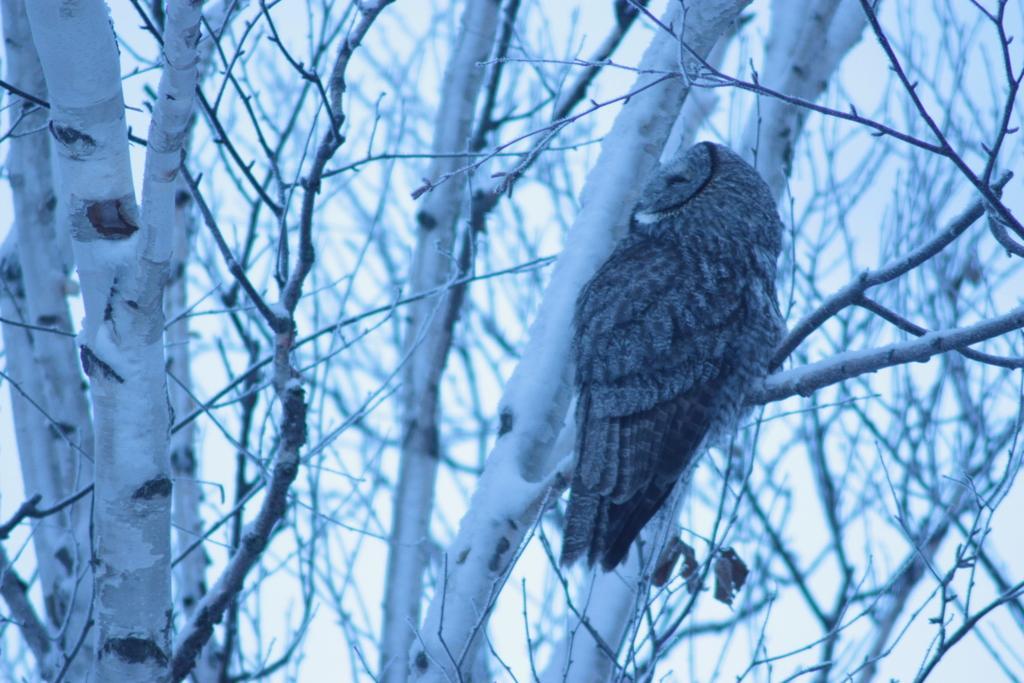How would you summarize this image in a sentence or two? In the foreground I can see an owl is sitting on the branch of a tree and tree trunks. This image is taken may be during a day. 